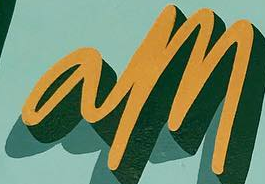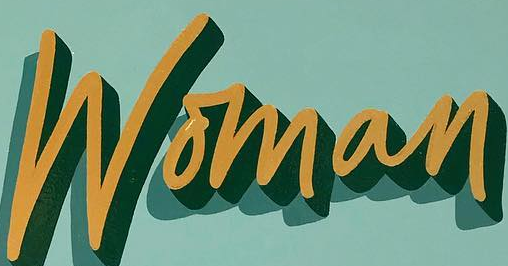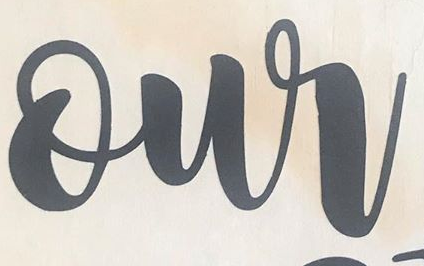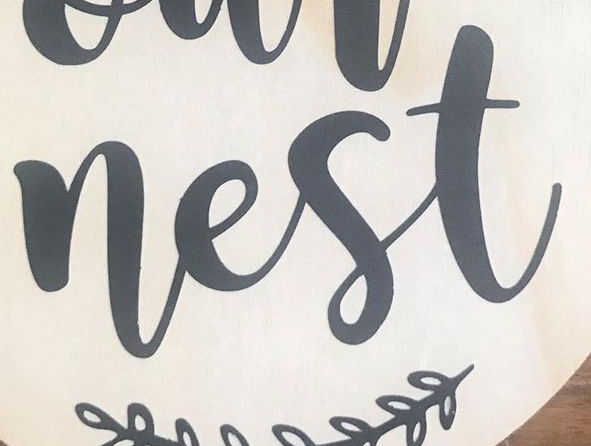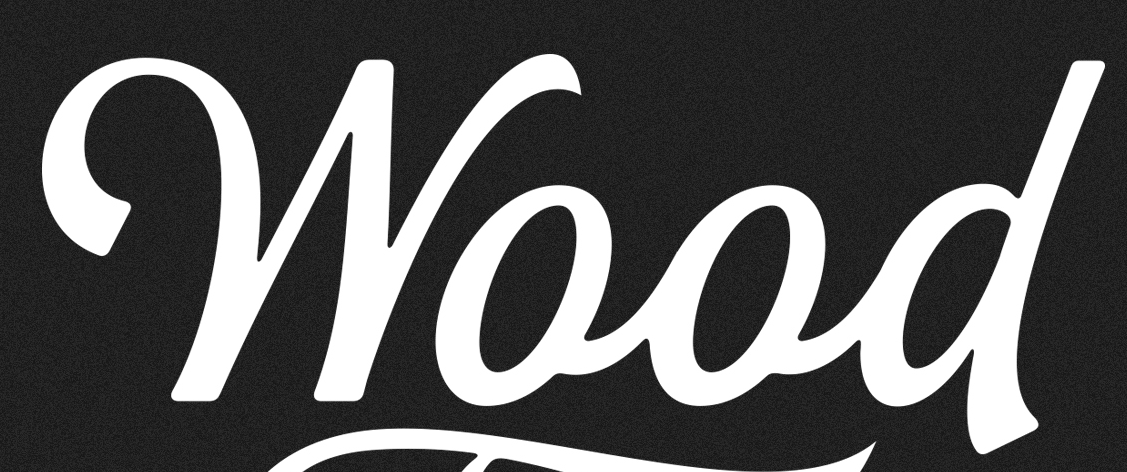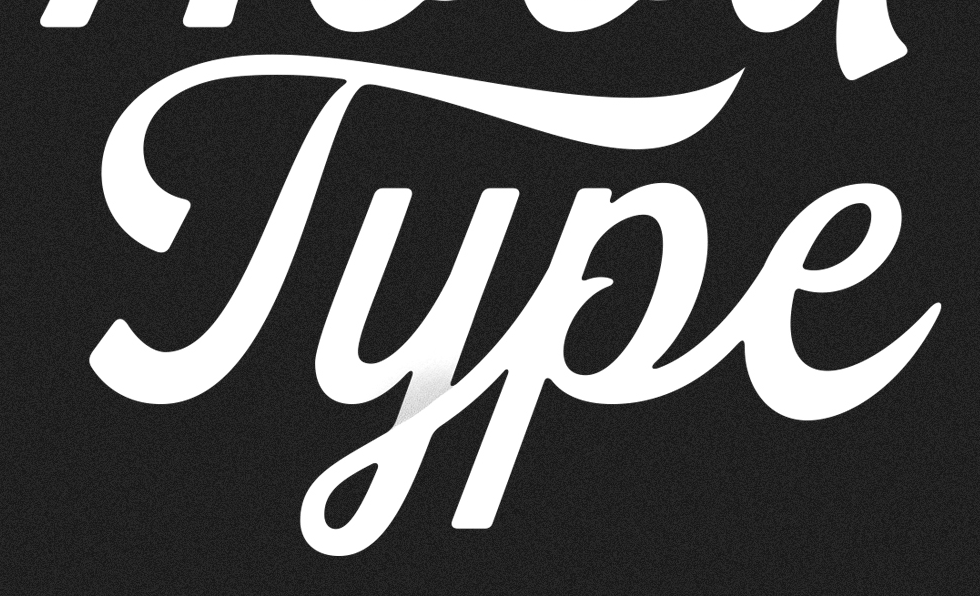Read the text from these images in sequence, separated by a semicolon. am; Woman; our; nest; Wood; Type 